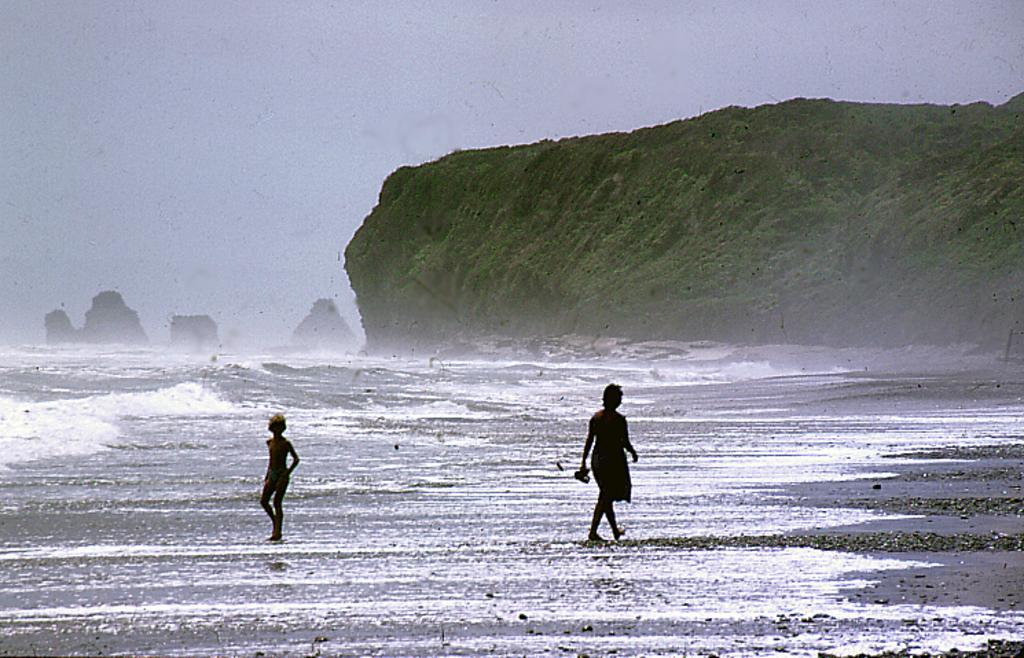Can you describe this image briefly? In this image, I can see two persons walking on a seashore. On the left side of the image, I can see water and rocks. In the background, there is a hill and the sky. 